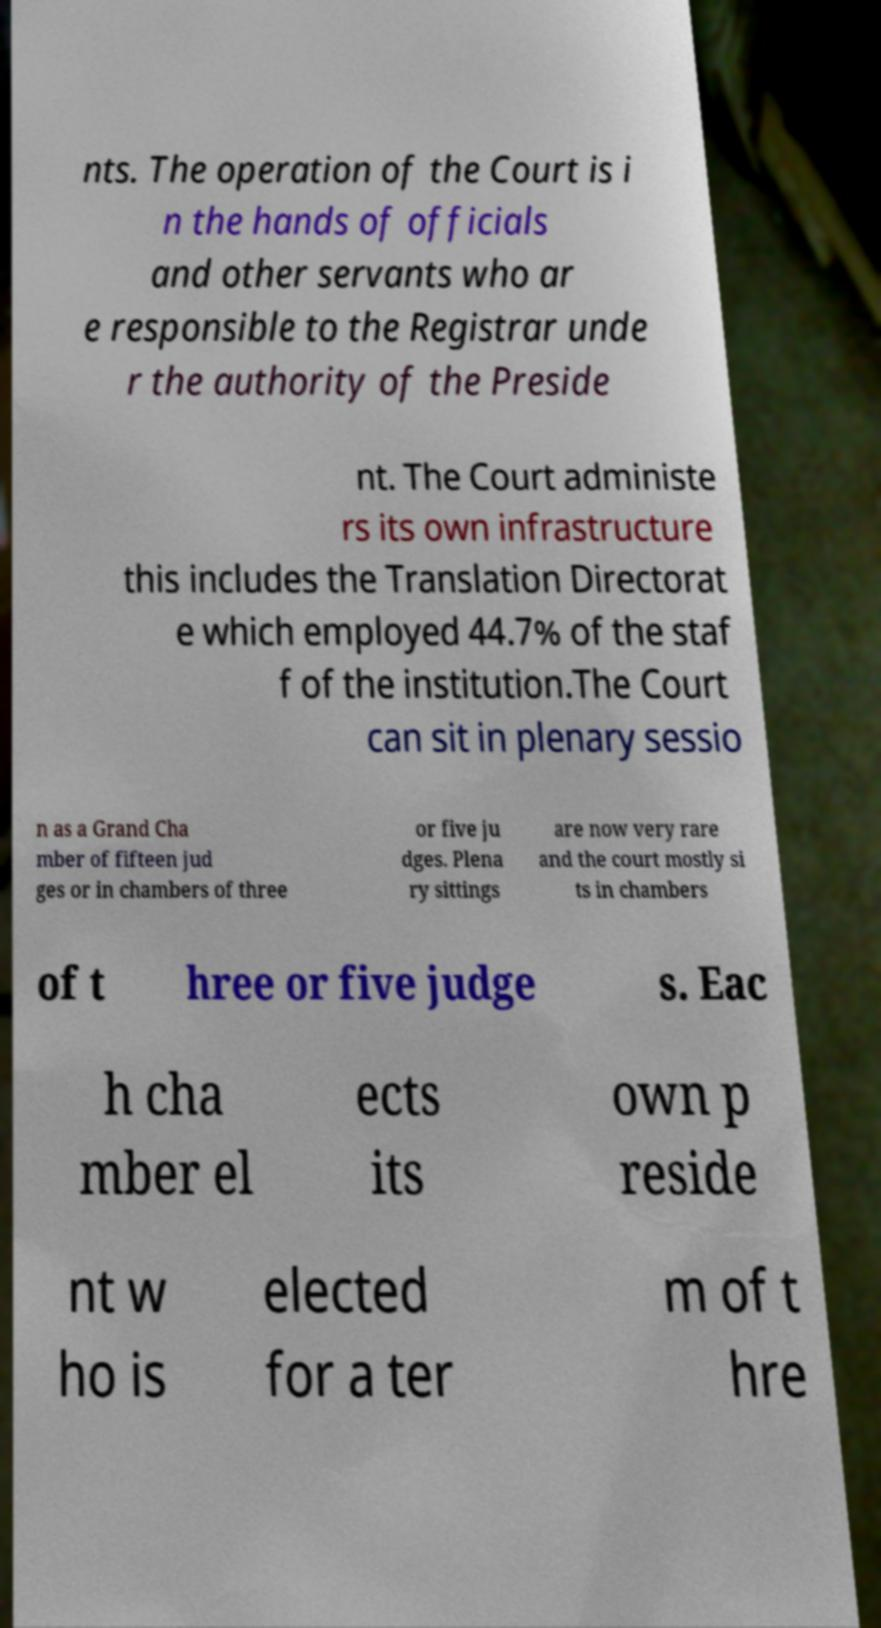Can you read and provide the text displayed in the image?This photo seems to have some interesting text. Can you extract and type it out for me? nts. The operation of the Court is i n the hands of officials and other servants who ar e responsible to the Registrar unde r the authority of the Preside nt. The Court administe rs its own infrastructure this includes the Translation Directorat e which employed 44.7% of the staf f of the institution.The Court can sit in plenary sessio n as a Grand Cha mber of fifteen jud ges or in chambers of three or five ju dges. Plena ry sittings are now very rare and the court mostly si ts in chambers of t hree or five judge s. Eac h cha mber el ects its own p reside nt w ho is elected for a ter m of t hre 